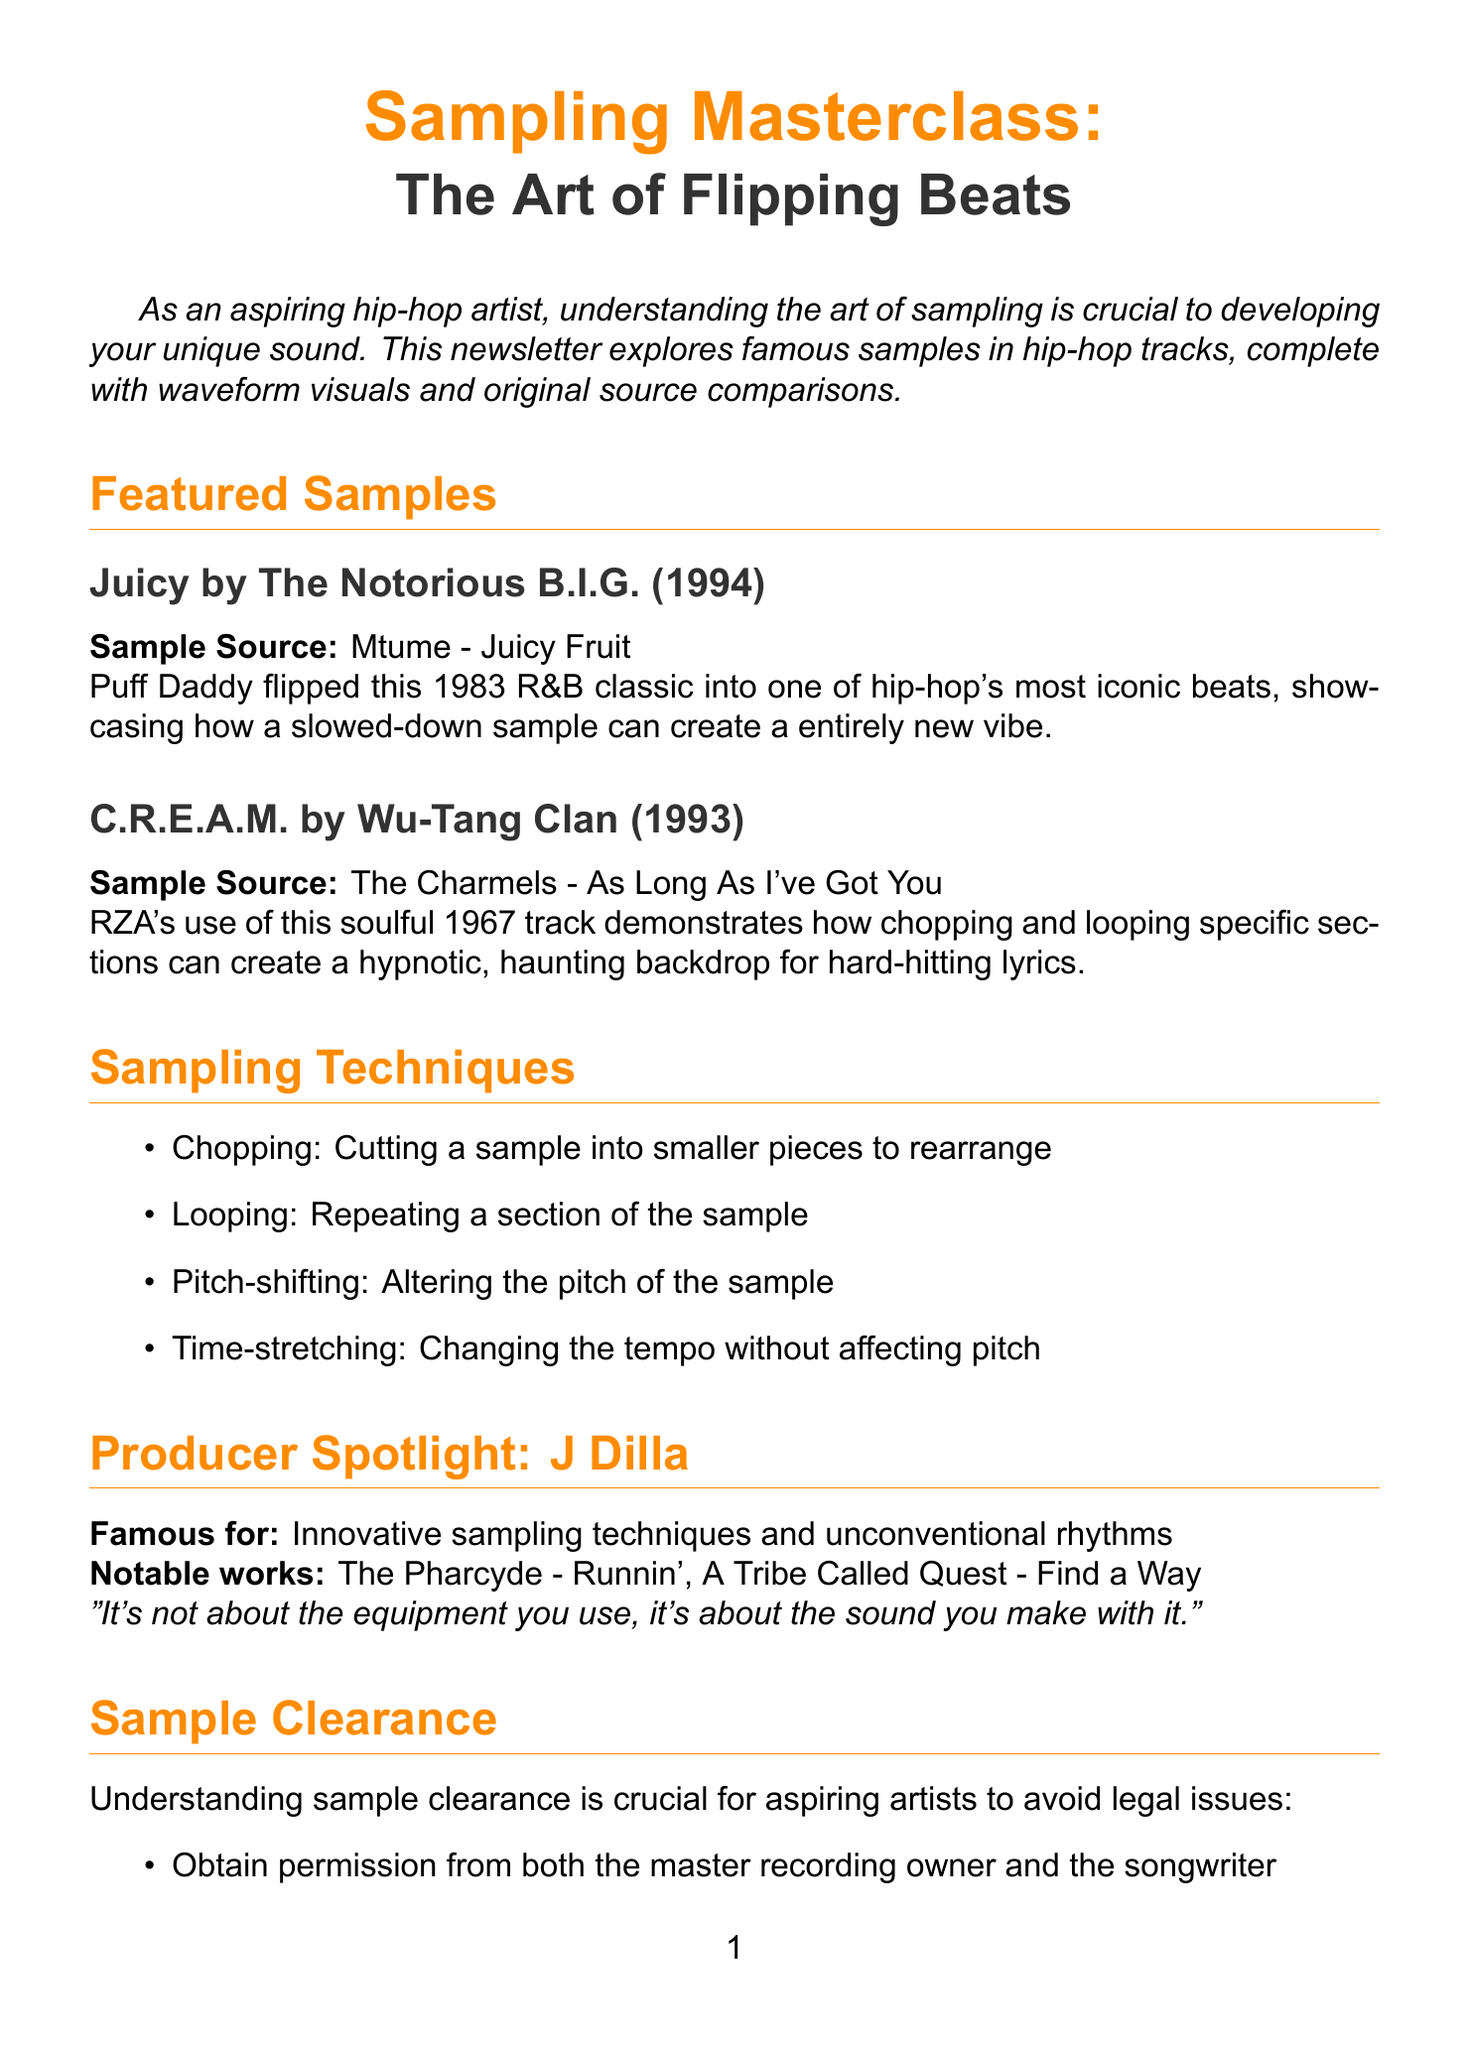What is the title of the newsletter? The title is clearly stated at the beginning of the document and is "Sampling Masterclass: The Art of Flipping Beats."
Answer: Sampling Masterclass: The Art of Flipping Beats Who is the producer spotlighted in the newsletter? The document highlights a specific producer known for his innovative techniques, which is J Dilla.
Answer: J Dilla What year was the track "Juicy" by The Notorious B.I.G. released? The release year for "Juicy" is explicitly listed in the document as 1994.
Answer: 1994 What sampling technique involves repeating a section? The document provides a list of sampling techniques, and the one that repeats a section is identified as looping.
Answer: Looping Which track is used for the DIY sampling exercise? The sample track for the DIY exercise is specifically mentioned to be "The Delfonics - Ready or Not Here I Come (Can't Hide from Love)."
Answer: The Delfonics - Ready or Not Here I Come (Can't Hide from Love) What is a key observation from the waveform analysis? The key observations from the waveform analysis highlight specific production techniques; one of them notes how Dre isolates and loops the iconic guitar riff.
Answer: Dre isolates and loops the iconic guitar riff What legal consideration is important for aspiring artists regarding sampling? The newsletter states that understanding sample clearance is crucial for avoiding legal issues when using samples in music.
Answer: Sample clearance is crucial When is the "Beat Battle: Sample Edition" event scheduled? The date for the "Beat Battle: Sample Edition" event is explicitly mentioned as August 5, 2023.
Answer: August 5, 2023 How many notable works are listed for J Dilla? The document lists two notable works for J Dilla, which are part of the producer spotlight section.
Answer: Two 